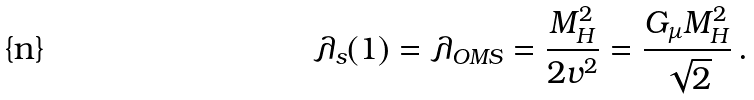Convert formula to latex. <formula><loc_0><loc_0><loc_500><loc_500>\lambda _ { s } ( 1 ) = \lambda _ { O M S } = \frac { M _ { H } ^ { 2 } } { 2 v ^ { 2 } } = \frac { G _ { \mu } M _ { H } ^ { 2 } } { \sqrt { 2 } } \, .</formula> 